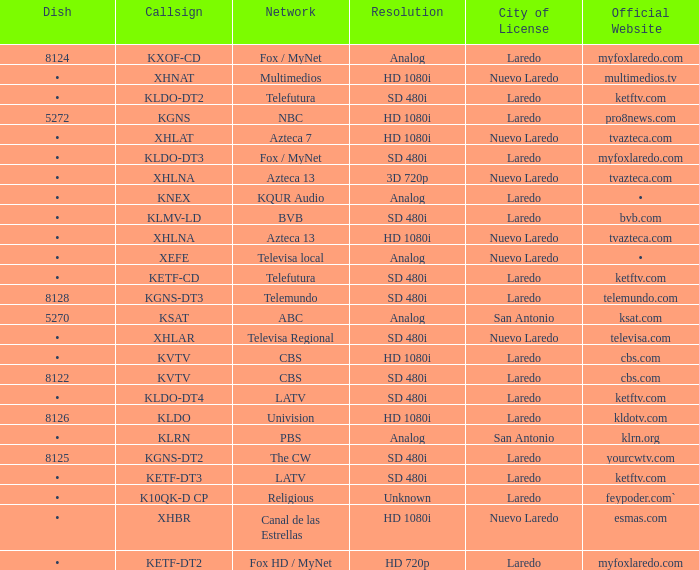Name the resolution with dish of 8126 HD 1080i. 